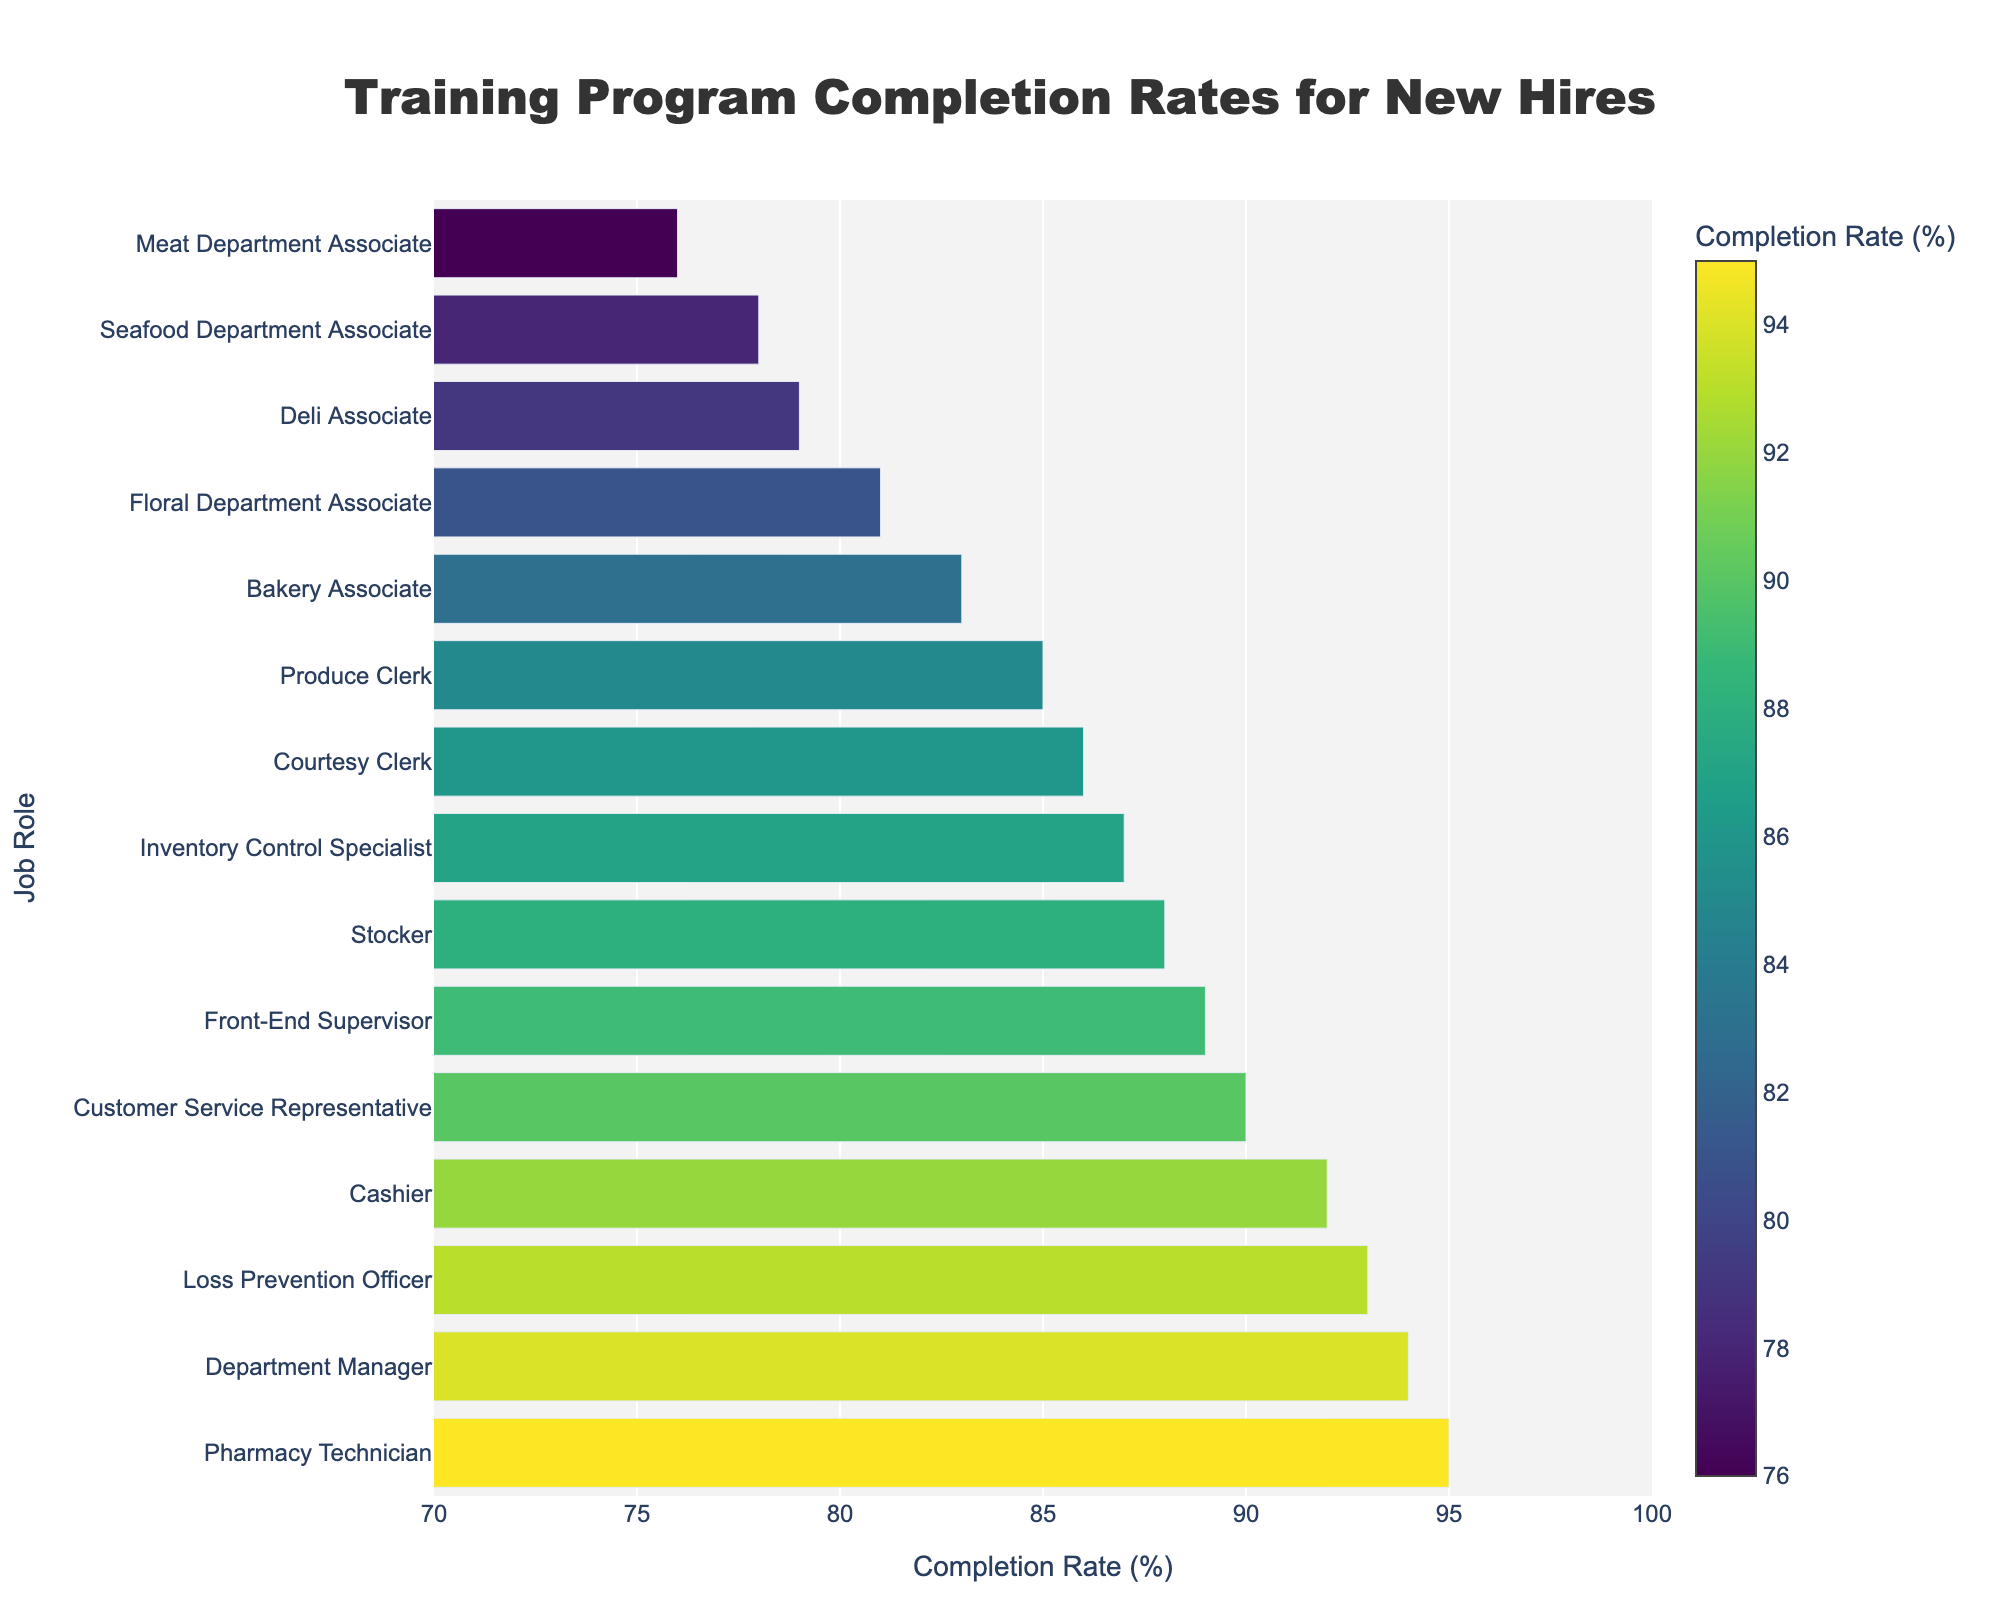What's the job role with the highest completion rate? Locate the bar with the highest value on the x-axis. The longest bar extends to 95% which corresponds to the Pharmacy Technician.
Answer: Pharmacy Technician Which job role has a completion rate of exactly 86%? Identify the bar that reaches 86% on the x-axis, which corresponds with the Courtesy Clerk on the y-axis.
Answer: Courtesy Clerk Compare the completion rates of the Deli Associate and the Seafood Department Associate. Which one has a higher rate? Locate the Deli Associate and Seafood Department Associate on the y-axis and compare their x-axis values. Deli Associate has a rate of 79%, and Seafood Department Associate has 78%.
Answer: Deli Associate What is the difference in completion rate between the Department Manager and Meat Department Associate? The Department Manager has a completion rate of 94%, and the Meat Department Associate has 76%. Calculate the difference: 94 - 76.
Answer: 18% Which job roles have completion rates above 90%? Identify all bars extending beyond the 90% mark on the x-axis. The roles include Cashier, Pharmacy Technician, Customer Service Representative, Department Manager, and Loss Prevention Officer.
Answer: Cashier, Pharmacy Technician, Customer Service Representative, Department Manager, Loss Prevention Officer What is the range of completion rates represented in the chart? Identify the highest and lowest values in the chart. The highest is 95% (Pharmacy Technician), and the lowest is 76% (Meat Department Associate). The range is 95 - 76.
Answer: 19% Which job role has the second highest completion rate and what is the rate? First, identify the highest completion rate (Pharmacy Technician, 95%). The second highest bar is slightly shorter, which belongs to the Department Manager at 94%.
Answer: Department Manager, 94% What is the average completion rate of the roles with rates below 80%? Identify roles with rates below 80%: Deli Associate (79%), Meat Department Associate (76%), and Seafood Department Associate (78%). Their average is: (79 + 76 + 78) / 3 = 77.67.
Answer: 77.67 Which job role has a completion rate closest to the median of all the rates? First, list all completion rates: 92, 88, 85, 79, 83, 76, 90, 95, 81, 78, 87, 93, 89, 94, 86. Sort and find the median position (8th in a 15-element list). The median value is 87%, and Inventory Control Specialist has that rate.
Answer: Inventory Control Specialist 